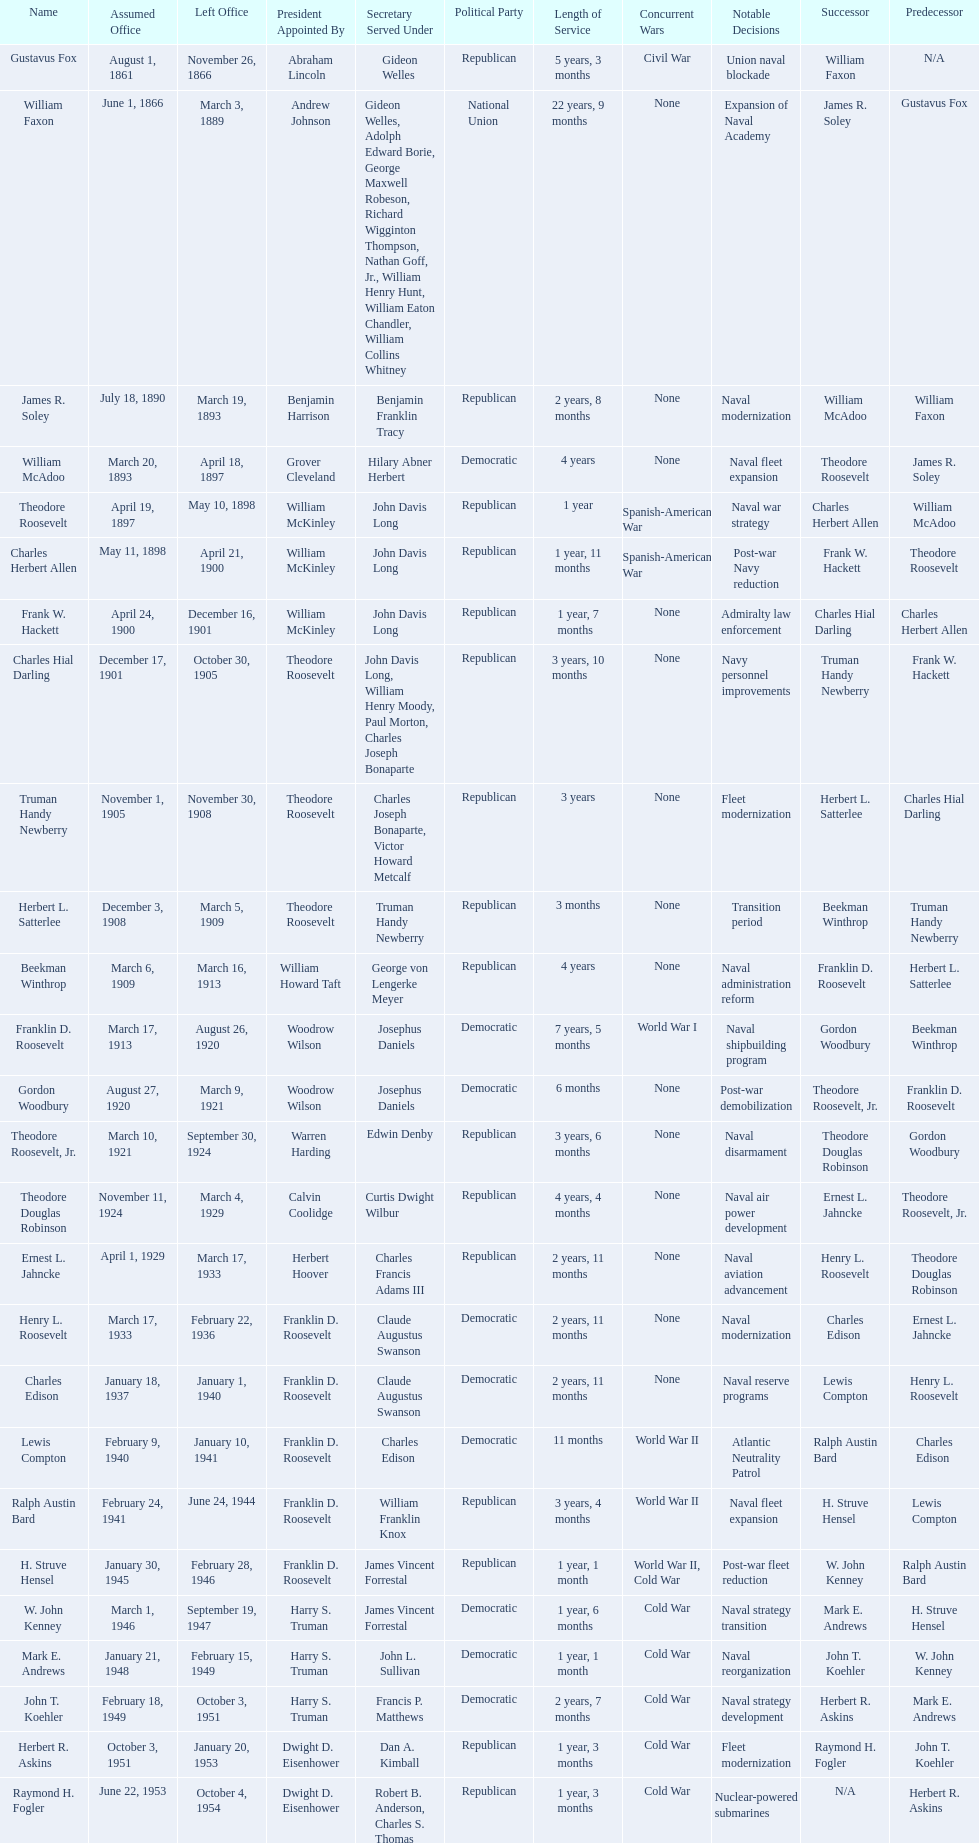Who was the first assistant secretary of the navy? Gustavus Fox. Can you give me this table as a dict? {'header': ['Name', 'Assumed Office', 'Left Office', 'President Appointed By', 'Secretary Served Under', 'Political Party', 'Length of Service', 'Concurrent Wars', 'Notable Decisions', 'Successor', 'Predecessor'], 'rows': [['Gustavus Fox', 'August 1, 1861', 'November 26, 1866', 'Abraham Lincoln', 'Gideon Welles', 'Republican', '5 years, 3 months', 'Civil War', 'Union naval blockade', 'William Faxon', 'N/A'], ['William Faxon', 'June 1, 1866', 'March 3, 1889', 'Andrew Johnson', 'Gideon Welles, Adolph Edward Borie, George Maxwell Robeson, Richard Wigginton Thompson, Nathan Goff, Jr., William Henry Hunt, William Eaton Chandler, William Collins Whitney', 'National Union', '22 years, 9 months', 'None', 'Expansion of Naval Academy', 'James R. Soley', 'Gustavus Fox'], ['James R. Soley', 'July 18, 1890', 'March 19, 1893', 'Benjamin Harrison', 'Benjamin Franklin Tracy', 'Republican', '2 years, 8 months', 'None', 'Naval modernization', 'William McAdoo', 'William Faxon'], ['William McAdoo', 'March 20, 1893', 'April 18, 1897', 'Grover Cleveland', 'Hilary Abner Herbert', 'Democratic', '4 years', 'None', 'Naval fleet expansion', 'Theodore Roosevelt', 'James R. Soley'], ['Theodore Roosevelt', 'April 19, 1897', 'May 10, 1898', 'William McKinley', 'John Davis Long', 'Republican', '1 year', 'Spanish-American War', 'Naval war strategy', 'Charles Herbert Allen', 'William McAdoo'], ['Charles Herbert Allen', 'May 11, 1898', 'April 21, 1900', 'William McKinley', 'John Davis Long', 'Republican', '1 year, 11 months', 'Spanish-American War', 'Post-war Navy reduction', 'Frank W. Hackett', 'Theodore Roosevelt'], ['Frank W. Hackett', 'April 24, 1900', 'December 16, 1901', 'William McKinley', 'John Davis Long', 'Republican', '1 year, 7 months', 'None', 'Admiralty law enforcement', 'Charles Hial Darling', 'Charles Herbert Allen'], ['Charles Hial Darling', 'December 17, 1901', 'October 30, 1905', 'Theodore Roosevelt', 'John Davis Long, William Henry Moody, Paul Morton, Charles Joseph Bonaparte', 'Republican', '3 years, 10 months', 'None', 'Navy personnel improvements', 'Truman Handy Newberry', 'Frank W. Hackett'], ['Truman Handy Newberry', 'November 1, 1905', 'November 30, 1908', 'Theodore Roosevelt', 'Charles Joseph Bonaparte, Victor Howard Metcalf', 'Republican', '3 years', 'None', 'Fleet modernization', 'Herbert L. Satterlee', 'Charles Hial Darling'], ['Herbert L. Satterlee', 'December 3, 1908', 'March 5, 1909', 'Theodore Roosevelt', 'Truman Handy Newberry', 'Republican', '3 months', 'None', 'Transition period', 'Beekman Winthrop', 'Truman Handy Newberry'], ['Beekman Winthrop', 'March 6, 1909', 'March 16, 1913', 'William Howard Taft', 'George von Lengerke Meyer', 'Republican', '4 years', 'None', 'Naval administration reform', 'Franklin D. Roosevelt', 'Herbert L. Satterlee'], ['Franklin D. Roosevelt', 'March 17, 1913', 'August 26, 1920', 'Woodrow Wilson', 'Josephus Daniels', 'Democratic', '7 years, 5 months', 'World War I', 'Naval shipbuilding program', 'Gordon Woodbury', 'Beekman Winthrop'], ['Gordon Woodbury', 'August 27, 1920', 'March 9, 1921', 'Woodrow Wilson', 'Josephus Daniels', 'Democratic', '6 months', 'None', 'Post-war demobilization', 'Theodore Roosevelt, Jr.', 'Franklin D. Roosevelt'], ['Theodore Roosevelt, Jr.', 'March 10, 1921', 'September 30, 1924', 'Warren Harding', 'Edwin Denby', 'Republican', '3 years, 6 months', 'None', 'Naval disarmament', 'Theodore Douglas Robinson', 'Gordon Woodbury'], ['Theodore Douglas Robinson', 'November 11, 1924', 'March 4, 1929', 'Calvin Coolidge', 'Curtis Dwight Wilbur', 'Republican', '4 years, 4 months', 'None', 'Naval air power development', 'Ernest L. Jahncke', 'Theodore Roosevelt, Jr.'], ['Ernest L. Jahncke', 'April 1, 1929', 'March 17, 1933', 'Herbert Hoover', 'Charles Francis Adams III', 'Republican', '2 years, 11 months', 'None', 'Naval aviation advancement', 'Henry L. Roosevelt', 'Theodore Douglas Robinson'], ['Henry L. Roosevelt', 'March 17, 1933', 'February 22, 1936', 'Franklin D. Roosevelt', 'Claude Augustus Swanson', 'Democratic', '2 years, 11 months', 'None', 'Naval modernization', 'Charles Edison', 'Ernest L. Jahncke'], ['Charles Edison', 'January 18, 1937', 'January 1, 1940', 'Franklin D. Roosevelt', 'Claude Augustus Swanson', 'Democratic', '2 years, 11 months', 'None', 'Naval reserve programs', 'Lewis Compton', 'Henry L. Roosevelt'], ['Lewis Compton', 'February 9, 1940', 'January 10, 1941', 'Franklin D. Roosevelt', 'Charles Edison', 'Democratic', '11 months', 'World War II', 'Atlantic Neutrality Patrol', 'Ralph Austin Bard', 'Charles Edison'], ['Ralph Austin Bard', 'February 24, 1941', 'June 24, 1944', 'Franklin D. Roosevelt', 'William Franklin Knox', 'Republican', '3 years, 4 months', 'World War II', 'Naval fleet expansion', 'H. Struve Hensel', 'Lewis Compton'], ['H. Struve Hensel', 'January 30, 1945', 'February 28, 1946', 'Franklin D. Roosevelt', 'James Vincent Forrestal', 'Republican', '1 year, 1 month', 'World War II, Cold War', 'Post-war fleet reduction', 'W. John Kenney', 'Ralph Austin Bard'], ['W. John Kenney', 'March 1, 1946', 'September 19, 1947', 'Harry S. Truman', 'James Vincent Forrestal', 'Democratic', '1 year, 6 months', 'Cold War', 'Naval strategy transition', 'Mark E. Andrews', 'H. Struve Hensel'], ['Mark E. Andrews', 'January 21, 1948', 'February 15, 1949', 'Harry S. Truman', 'John L. Sullivan', 'Democratic', '1 year, 1 month', 'Cold War', 'Naval reorganization', 'John T. Koehler', 'W. John Kenney'], ['John T. Koehler', 'February 18, 1949', 'October 3, 1951', 'Harry S. Truman', 'Francis P. Matthews', 'Democratic', '2 years, 7 months', 'Cold War', 'Naval strategy development', 'Herbert R. Askins', 'Mark E. Andrews'], ['Herbert R. Askins', 'October 3, 1951', 'January 20, 1953', 'Dwight D. Eisenhower', 'Dan A. Kimball', 'Republican', '1 year, 3 months', 'Cold War', 'Fleet modernization', 'Raymond H. Fogler', 'John T. Koehler'], ['Raymond H. Fogler', 'June 22, 1953', 'October 4, 1954', 'Dwight D. Eisenhower', 'Robert B. Anderson, Charles S. Thomas', 'Republican', '1 year, 3 months', 'Cold War', 'Nuclear-powered submarines', 'N/A', 'Herbert R. Askins']]} 